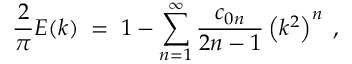<formula> <loc_0><loc_0><loc_500><loc_500>{ \frac { 2 } { \pi } } E ( k ) \, = \, 1 - \sum _ { n = 1 } ^ { \infty } { \frac { c _ { 0 n } } { 2 n - 1 } } \left ( k ^ { 2 } \right ) ^ { n } \, ,</formula> 